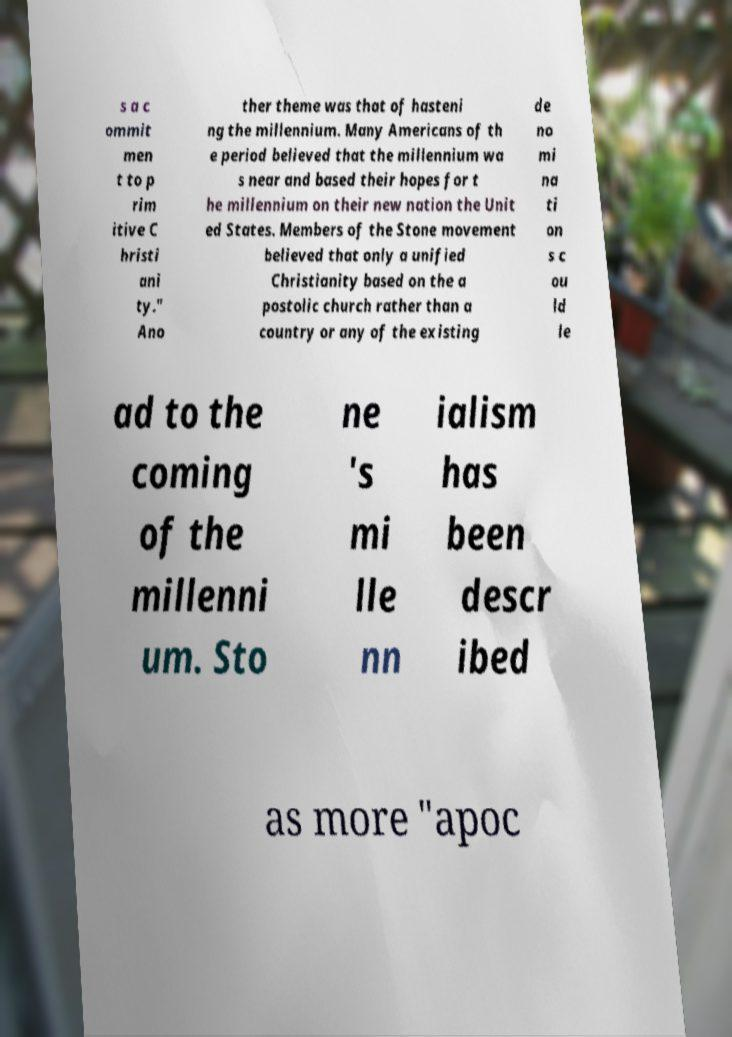Can you read and provide the text displayed in the image?This photo seems to have some interesting text. Can you extract and type it out for me? s a c ommit men t to p rim itive C hristi ani ty." Ano ther theme was that of hasteni ng the millennium. Many Americans of th e period believed that the millennium wa s near and based their hopes for t he millennium on their new nation the Unit ed States. Members of the Stone movement believed that only a unified Christianity based on the a postolic church rather than a country or any of the existing de no mi na ti on s c ou ld le ad to the coming of the millenni um. Sto ne 's mi lle nn ialism has been descr ibed as more "apoc 